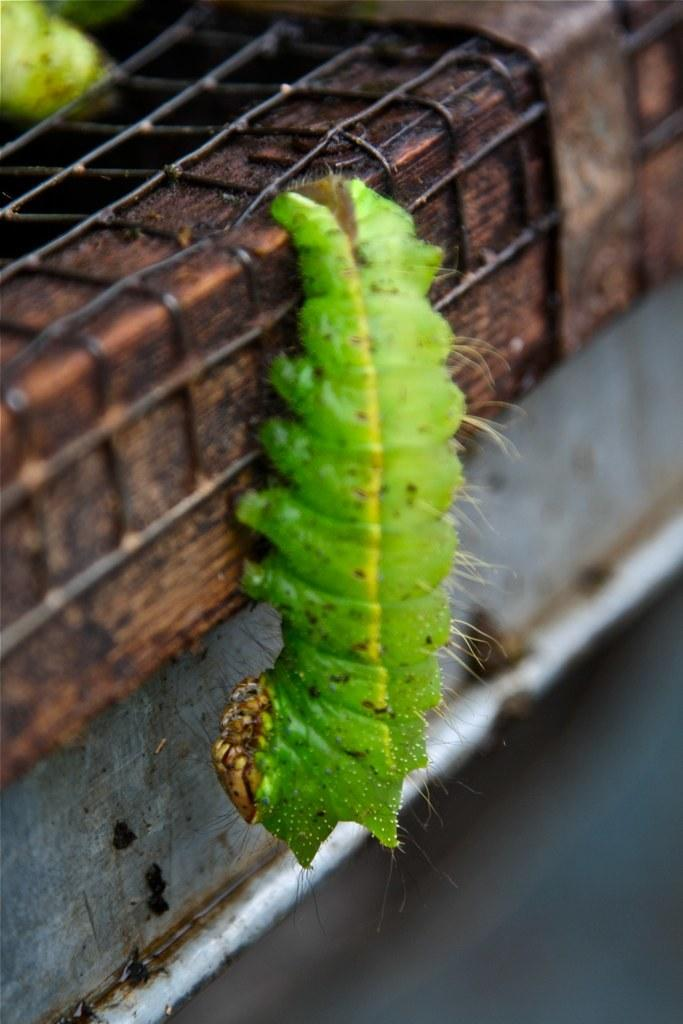What type of animal is in the picture? There is a green color caterpillar in the picture. What can be seen in the background of the picture? There is a metal fence in the picture. What color is the balloon held by the stranger in the picture? There is no balloon or stranger present in the picture; it only features a green color caterpillar and a metal fence. What type of mint is growing near the caterpillar in the picture? There is no mint present in the picture; it only features a green color caterpillar and a metal fence. 